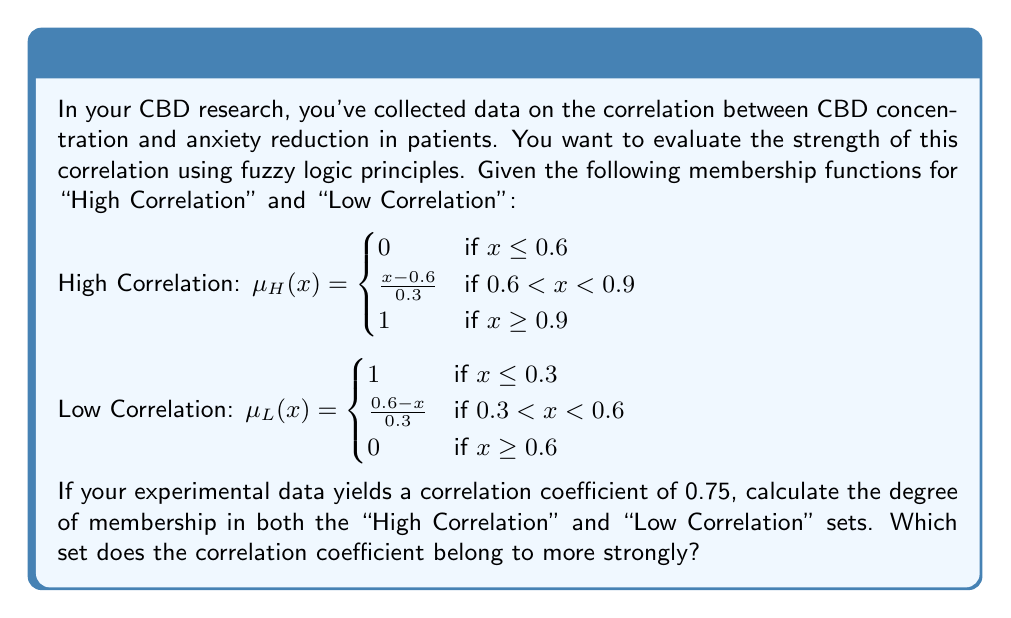Show me your answer to this math problem. To solve this problem, we need to evaluate the membership functions for both "High Correlation" and "Low Correlation" at the given correlation coefficient of 0.75.

1. Evaluating $\mu_H(0.75)$ (High Correlation):
   Since 0.6 < 0.75 < 0.9, we use the second case of the $\mu_H(x)$ function:
   $\mu_H(0.75) = \frac{0.75 - 0.6}{0.3} = \frac{0.15}{0.3} = 0.5$

2. Evaluating $\mu_L(0.75)$ (Low Correlation):
   Since 0.75 > 0.6, we use the third case of the $\mu_L(x)$ function:
   $\mu_L(0.75) = 0$

3. Comparing the degrees of membership:
   High Correlation: 0.5
   Low Correlation: 0

The correlation coefficient of 0.75 has a higher degree of membership in the "High Correlation" set (0.5) compared to the "Low Correlation" set (0).

Therefore, the correlation coefficient belongs more strongly to the "High Correlation" set.
Answer: The degree of membership in the "High Correlation" set is 0.5, and in the "Low Correlation" set is 0. The correlation coefficient of 0.75 belongs more strongly to the "High Correlation" set. 